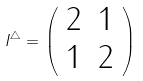Convert formula to latex. <formula><loc_0><loc_0><loc_500><loc_500>I ^ { \triangle } = \left ( \begin{array} { c c } 2 & 1 \\ 1 & 2 \end{array} \right )</formula> 